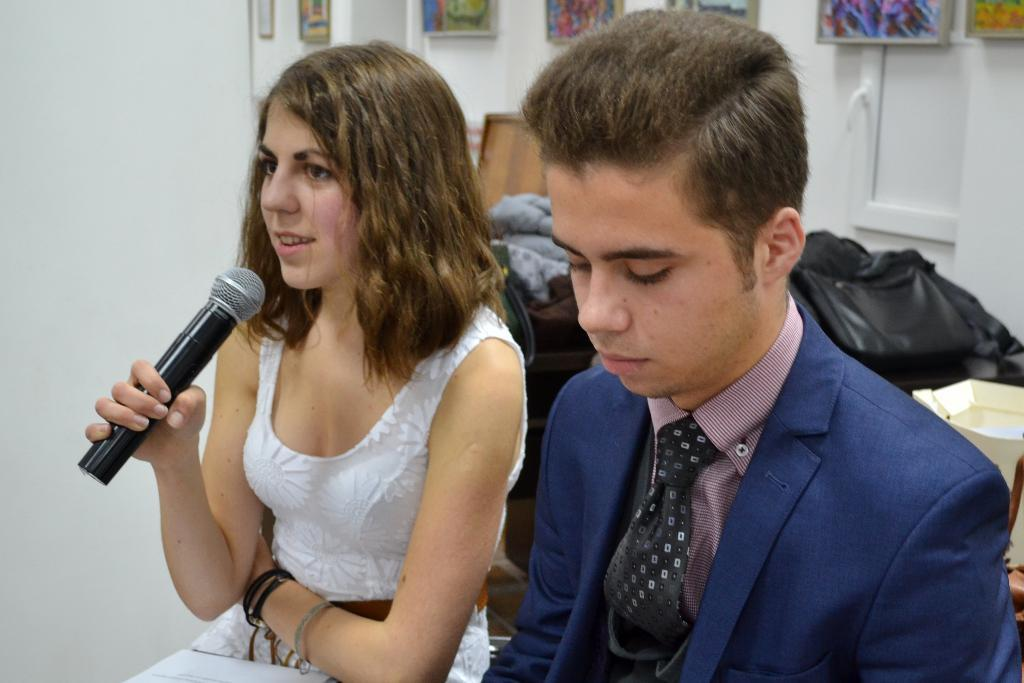How many people are present in the image? There are two people in the image, a man and a woman. What are the man and woman doing in the image? The man and woman are seated. Can you describe the woman with the microphone? There is a woman speaking with a microphone in the image. What can be seen on the wall in the image? There are photo frames on the wall. What type of snake can be seen slithering on the sidewalk in the image? There is no snake or sidewalk present in the image. Is the camera visible in the image? The image does not show a camera, only the man, woman, and woman with a microphone. 